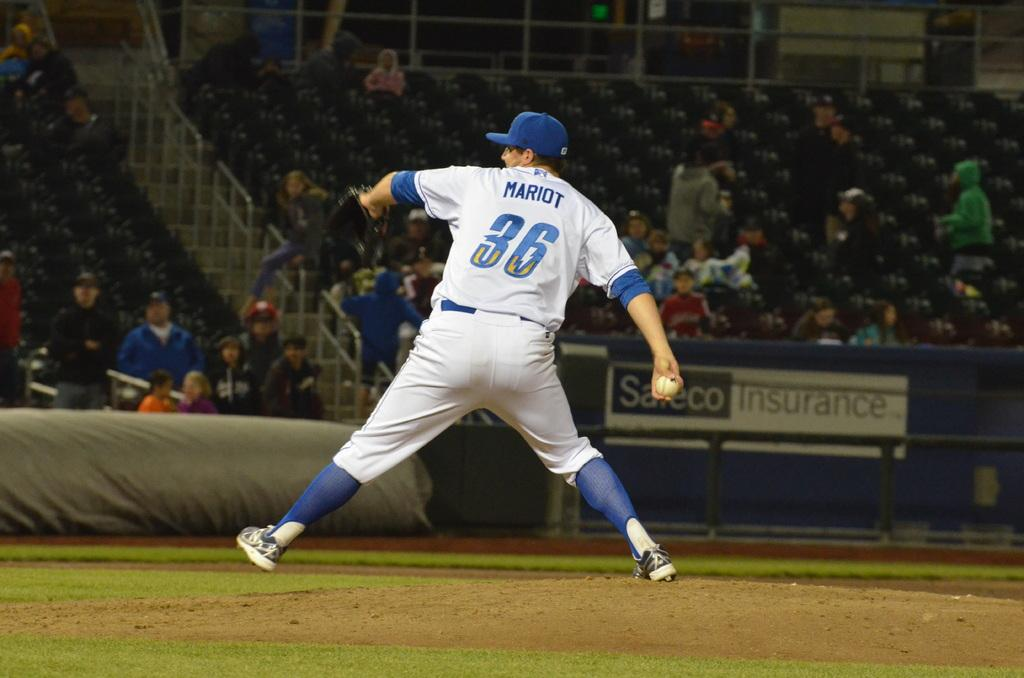<image>
Provide a brief description of the given image. A baseball player with the number 36 and his name written on the back of his jersey getting ready to throw the ball. 